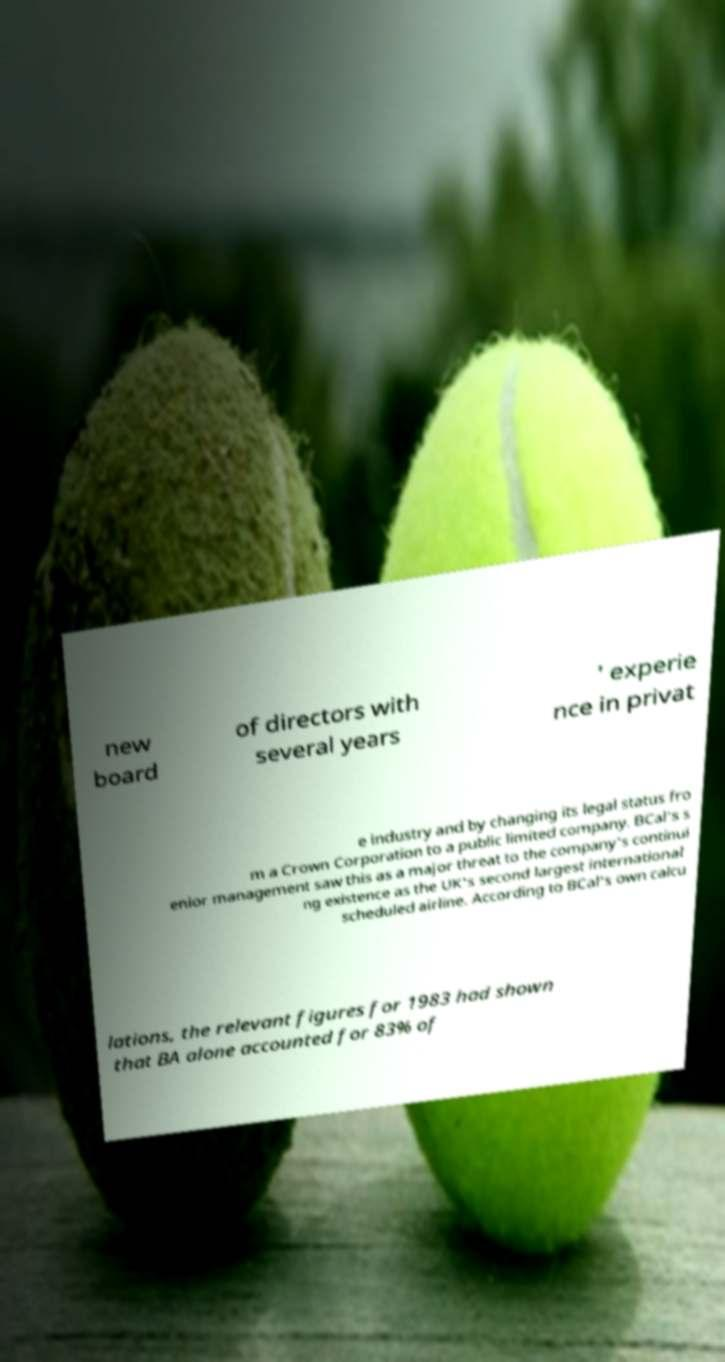Could you extract and type out the text from this image? new board of directors with several years ' experie nce in privat e industry and by changing its legal status fro m a Crown Corporation to a public limited company. BCal's s enior management saw this as a major threat to the company's continui ng existence as the UK's second largest international scheduled airline. According to BCal's own calcu lations, the relevant figures for 1983 had shown that BA alone accounted for 83% of 